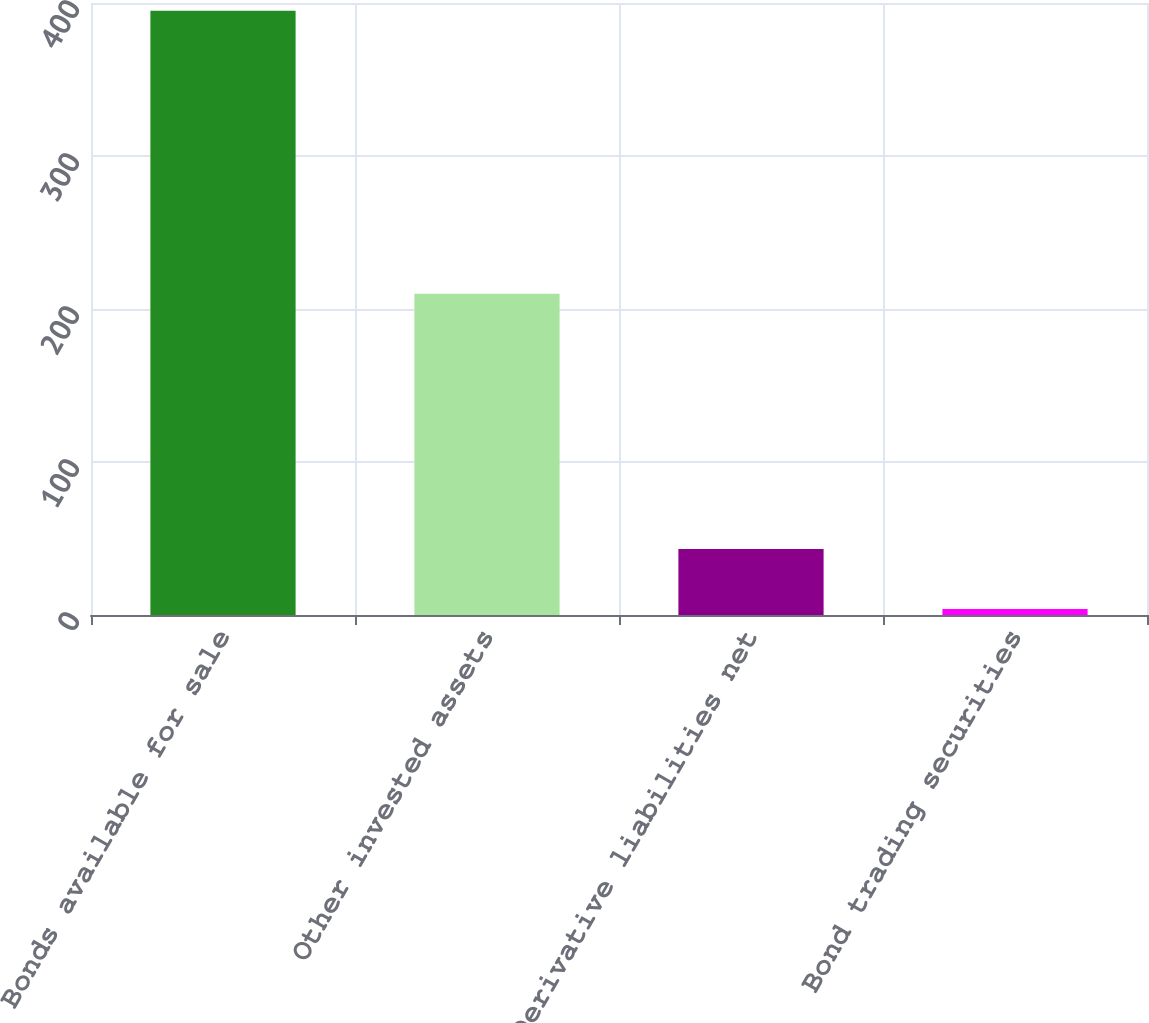Convert chart to OTSL. <chart><loc_0><loc_0><loc_500><loc_500><bar_chart><fcel>Bonds available for sale<fcel>Other invested assets<fcel>Derivative liabilities net<fcel>Bond trading securities<nl><fcel>395<fcel>210<fcel>43.1<fcel>4<nl></chart> 